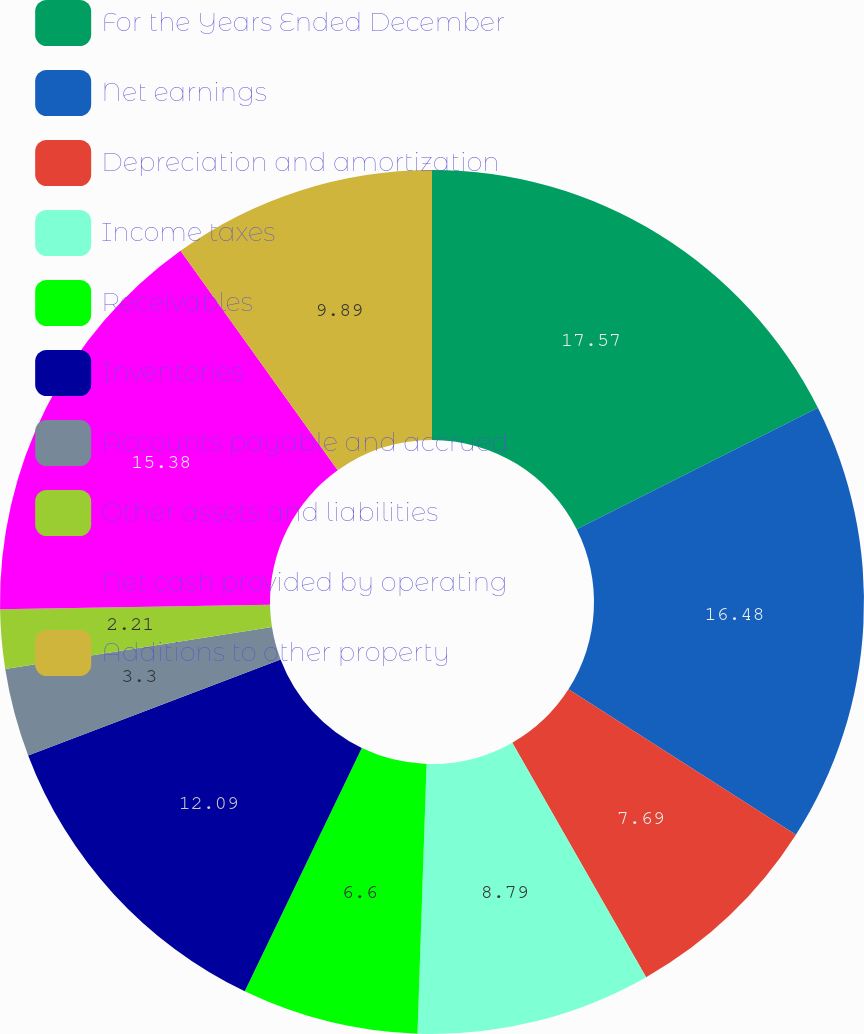Convert chart to OTSL. <chart><loc_0><loc_0><loc_500><loc_500><pie_chart><fcel>For the Years Ended December<fcel>Net earnings<fcel>Depreciation and amortization<fcel>Income taxes<fcel>Receivables<fcel>Inventories<fcel>Accounts payable and accrued<fcel>Other assets and liabilities<fcel>Net cash provided by operating<fcel>Additions to other property<nl><fcel>17.58%<fcel>16.48%<fcel>7.69%<fcel>8.79%<fcel>6.6%<fcel>12.09%<fcel>3.3%<fcel>2.21%<fcel>15.38%<fcel>9.89%<nl></chart> 